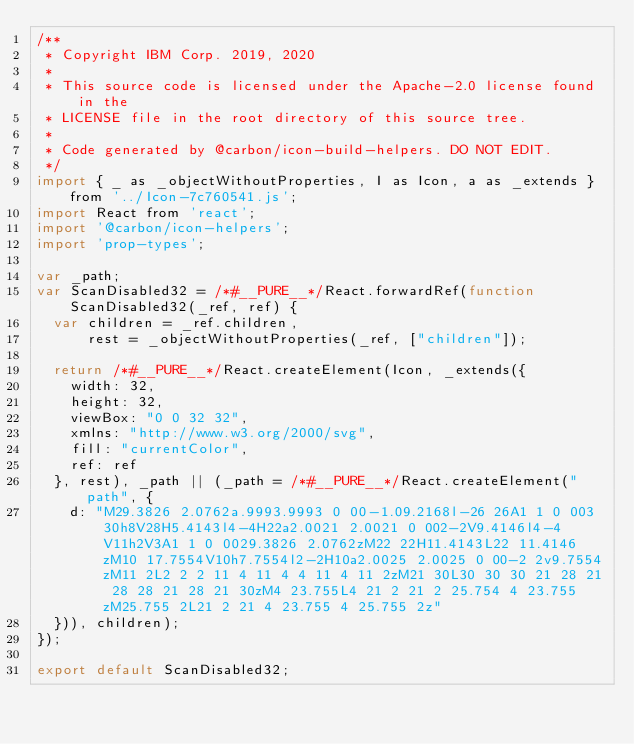<code> <loc_0><loc_0><loc_500><loc_500><_JavaScript_>/**
 * Copyright IBM Corp. 2019, 2020
 *
 * This source code is licensed under the Apache-2.0 license found in the
 * LICENSE file in the root directory of this source tree.
 *
 * Code generated by @carbon/icon-build-helpers. DO NOT EDIT.
 */
import { _ as _objectWithoutProperties, I as Icon, a as _extends } from '../Icon-7c760541.js';
import React from 'react';
import '@carbon/icon-helpers';
import 'prop-types';

var _path;
var ScanDisabled32 = /*#__PURE__*/React.forwardRef(function ScanDisabled32(_ref, ref) {
  var children = _ref.children,
      rest = _objectWithoutProperties(_ref, ["children"]);

  return /*#__PURE__*/React.createElement(Icon, _extends({
    width: 32,
    height: 32,
    viewBox: "0 0 32 32",
    xmlns: "http://www.w3.org/2000/svg",
    fill: "currentColor",
    ref: ref
  }, rest), _path || (_path = /*#__PURE__*/React.createElement("path", {
    d: "M29.3826 2.0762a.9993.9993 0 00-1.09.2168l-26 26A1 1 0 003 30h8V28H5.4143l4-4H22a2.0021 2.0021 0 002-2V9.4146l4-4V11h2V3A1 1 0 0029.3826 2.0762zM22 22H11.4143L22 11.4146zM10 17.7554V10h7.7554l2-2H10a2.0025 2.0025 0 00-2 2v9.7554zM11 2L2 2 2 11 4 11 4 4 11 4 11 2zM21 30L30 30 30 21 28 21 28 28 21 28 21 30zM4 23.755L4 21 2 21 2 25.754 4 23.755zM25.755 2L21 2 21 4 23.755 4 25.755 2z"
  })), children);
});

export default ScanDisabled32;
</code> 